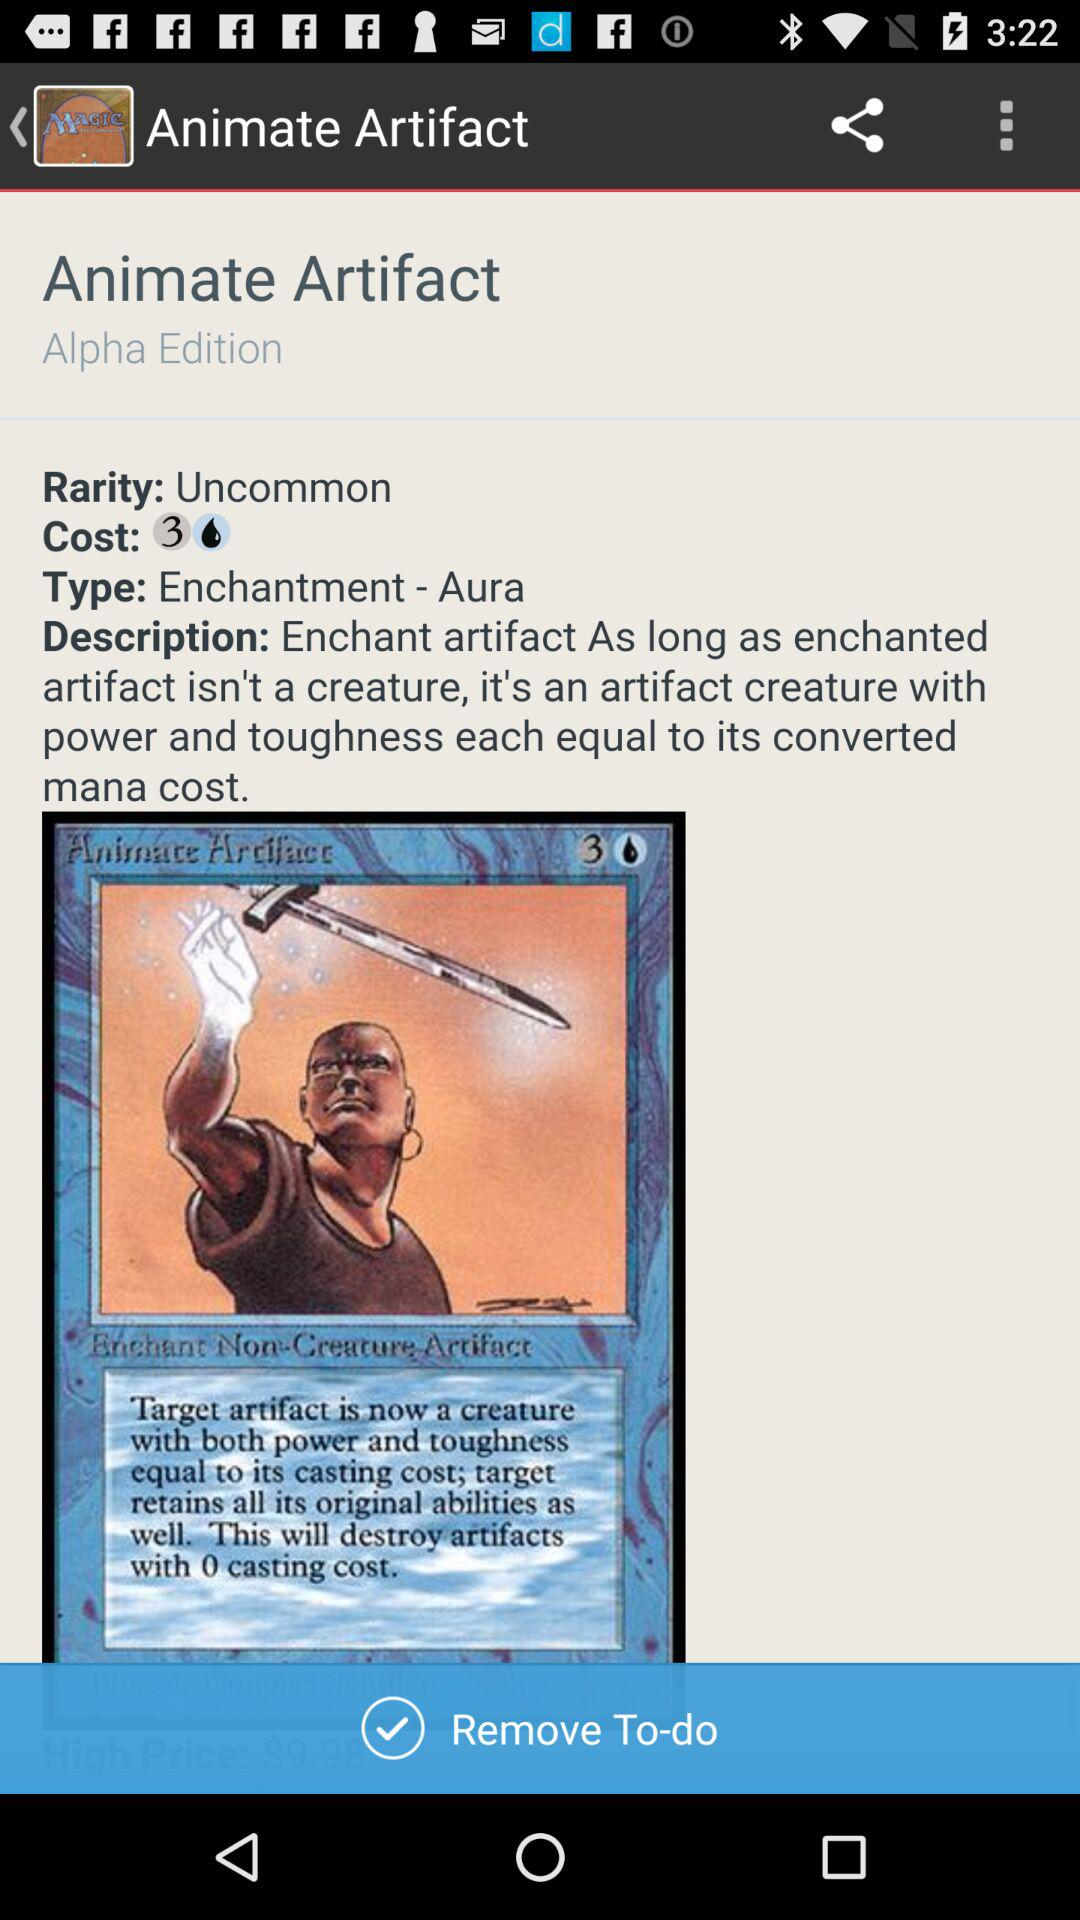What is the given rarity? The given rarity is uncommon. 